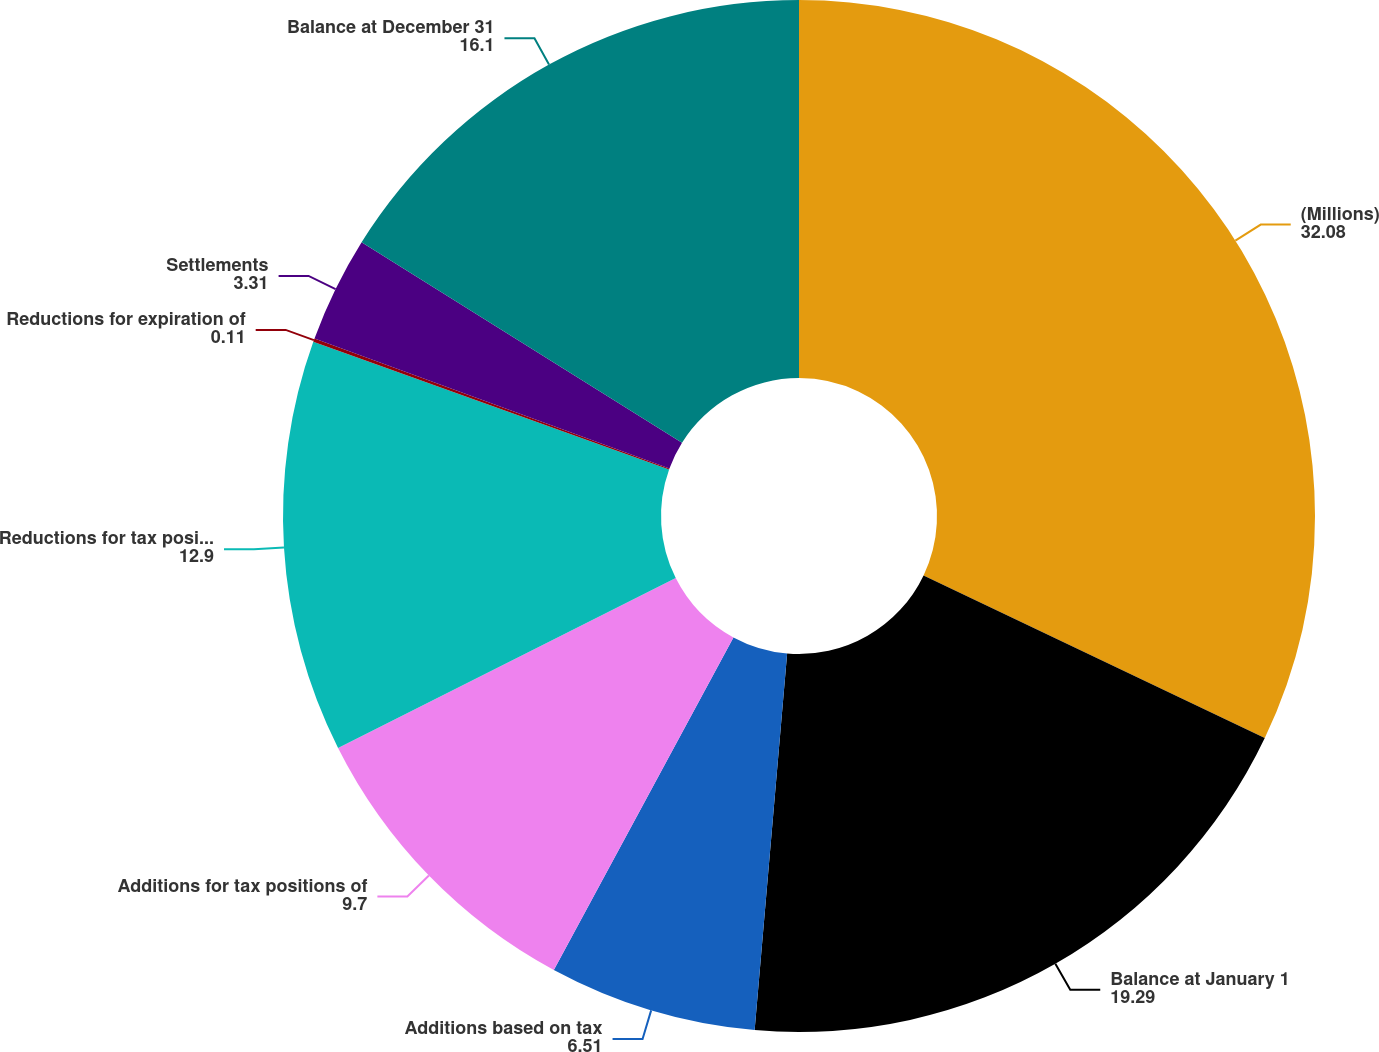Convert chart to OTSL. <chart><loc_0><loc_0><loc_500><loc_500><pie_chart><fcel>(Millions)<fcel>Balance at January 1<fcel>Additions based on tax<fcel>Additions for tax positions of<fcel>Reductions for tax positions<fcel>Reductions for expiration of<fcel>Settlements<fcel>Balance at December 31<nl><fcel>32.08%<fcel>19.29%<fcel>6.51%<fcel>9.7%<fcel>12.9%<fcel>0.11%<fcel>3.31%<fcel>16.1%<nl></chart> 